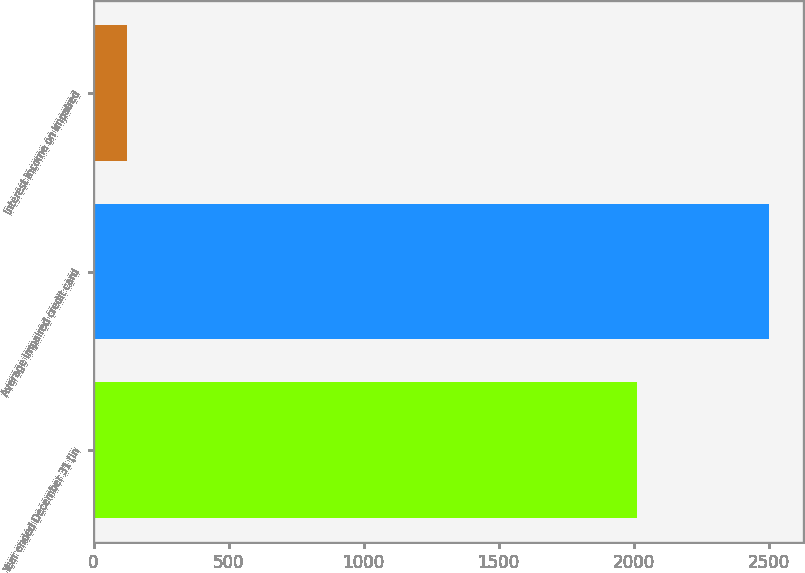Convert chart to OTSL. <chart><loc_0><loc_0><loc_500><loc_500><bar_chart><fcel>Year ended December 31 (in<fcel>Average impaired credit card<fcel>Interest income on impaired<nl><fcel>2014<fcel>2503<fcel>123<nl></chart> 